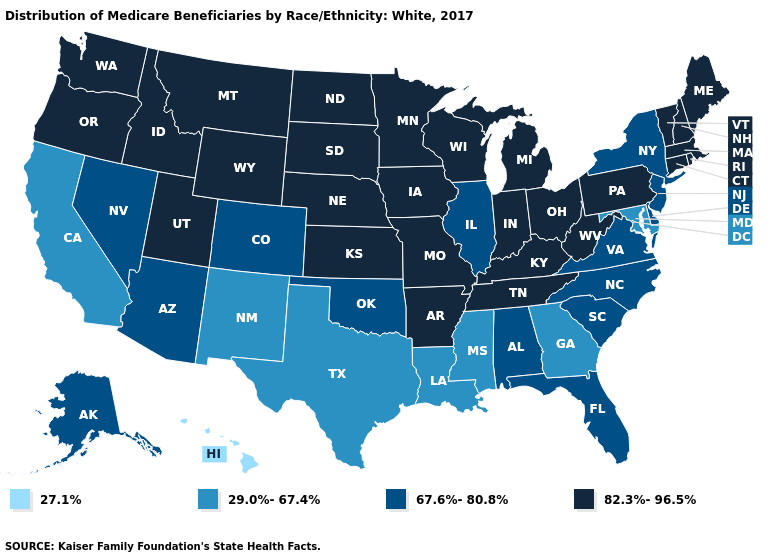Does Hawaii have the lowest value in the West?
Quick response, please. Yes. Does Illinois have the highest value in the USA?
Write a very short answer. No. What is the value of Kansas?
Short answer required. 82.3%-96.5%. Name the states that have a value in the range 27.1%?
Keep it brief. Hawaii. Does Alaska have the lowest value in the USA?
Answer briefly. No. Among the states that border Mississippi , does Tennessee have the highest value?
Keep it brief. Yes. What is the value of Washington?
Give a very brief answer. 82.3%-96.5%. What is the highest value in the South ?
Quick response, please. 82.3%-96.5%. Which states have the highest value in the USA?
Give a very brief answer. Arkansas, Connecticut, Idaho, Indiana, Iowa, Kansas, Kentucky, Maine, Massachusetts, Michigan, Minnesota, Missouri, Montana, Nebraska, New Hampshire, North Dakota, Ohio, Oregon, Pennsylvania, Rhode Island, South Dakota, Tennessee, Utah, Vermont, Washington, West Virginia, Wisconsin, Wyoming. Among the states that border West Virginia , which have the lowest value?
Write a very short answer. Maryland. Does the first symbol in the legend represent the smallest category?
Concise answer only. Yes. What is the lowest value in states that border Virginia?
Answer briefly. 29.0%-67.4%. Name the states that have a value in the range 27.1%?
Keep it brief. Hawaii. 